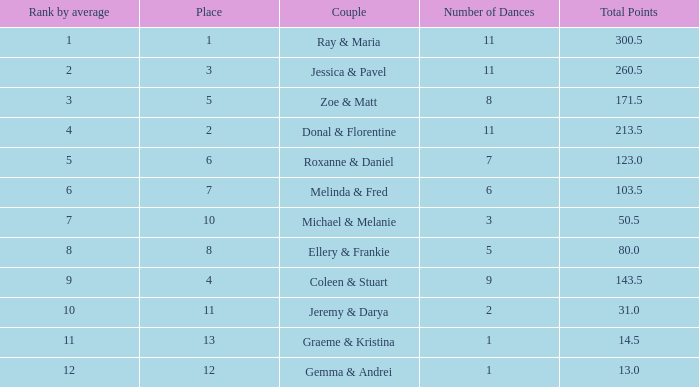What is the name of the couple with an average of 15.9? Coleen & Stuart. 